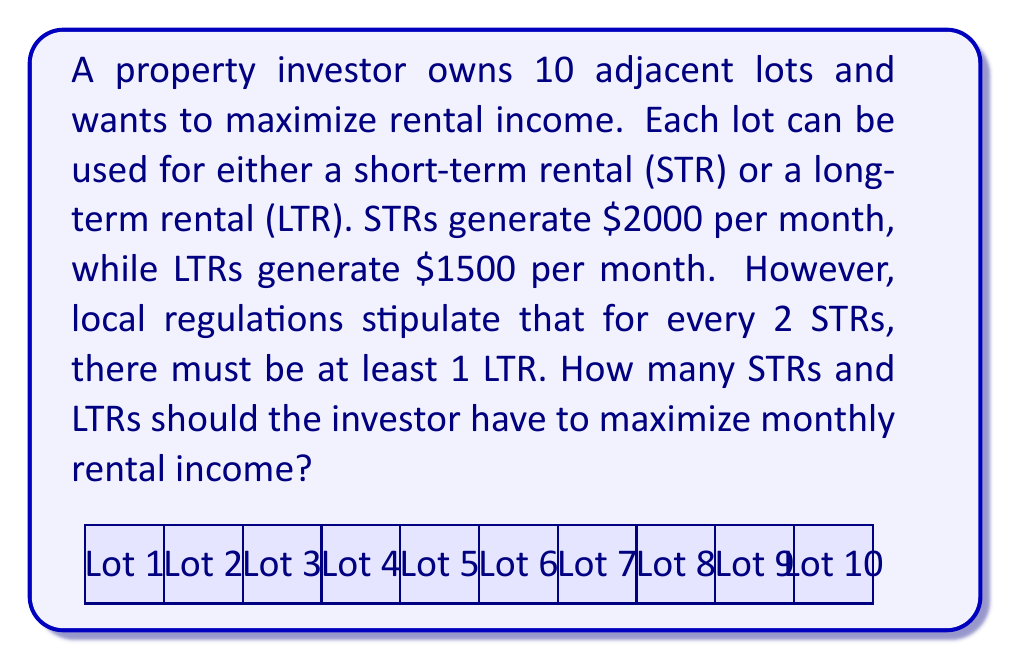Provide a solution to this math problem. Let's approach this step-by-step:

1) Let $x$ be the number of STRs and $y$ be the number of LTRs.

2) We know that $x + y = 10$ (total lots).

3) The regulation states that for every 2 STRs, there must be at least 1 LTR. This can be expressed as:
   $$\frac{x}{2} \leq y$$

4) Our goal is to maximize the monthly income, which can be expressed as:
   $$2000x + 1500y$$

5) Given the constraint $x + y = 10$, we can express $y$ in terms of $x$:
   $$y = 10 - x$$

6) Substituting this into the regulation inequality:
   $$\frac{x}{2} \leq 10 - x$$
   $$x \leq 20 - 2x$$
   $$3x \leq 20$$
   $$x \leq \frac{20}{3} \approx 6.67$$

7) Since $x$ must be an integer, the maximum value it can take is 6.

8) Therefore, the optimal combination is 6 STRs and 4 LTRs.

9) We can verify this satisfies the regulation: $\frac{6}{2} = 3 \leq 4$

10) The maximum monthly income is:
    $$6 * 2000 + 4 * 1500 = 12000 + 6000 = 18000$$
Answer: 6 STRs and 4 LTRs, generating $18000 per month. 